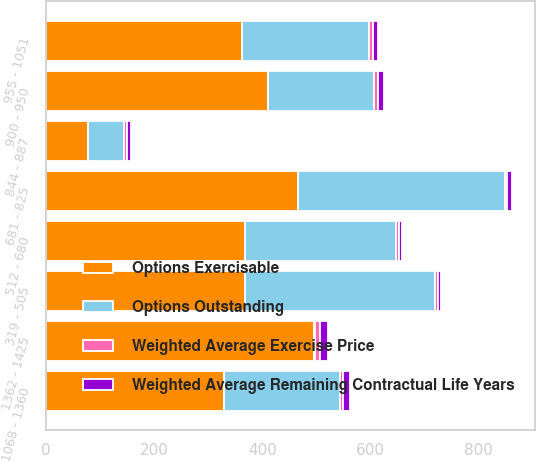<chart> <loc_0><loc_0><loc_500><loc_500><stacked_bar_chart><ecel><fcel>319 - 505<fcel>512 - 680<fcel>681 - 825<fcel>844 - 887<fcel>900 - 950<fcel>955 - 1051<fcel>1068 - 1360<fcel>1362 - 1425<nl><fcel>Options Exercisable<fcel>368<fcel>369<fcel>466<fcel>77<fcel>411<fcel>362<fcel>330<fcel>495<nl><fcel>Weighted Average Exercise Price<fcel>6.11<fcel>6.12<fcel>4.67<fcel>5.1<fcel>7.97<fcel>7.27<fcel>5.96<fcel>9.09<nl><fcel>Weighted Average Remaining Contractual Life Years<fcel>4.83<fcel>5.84<fcel>7.65<fcel>8.84<fcel>9.49<fcel>10.25<fcel>12.48<fcel>14.24<nl><fcel>Options Outstanding<fcel>351<fcel>278<fcel>383<fcel>67<fcel>196<fcel>235<fcel>214<fcel>3<nl></chart> 